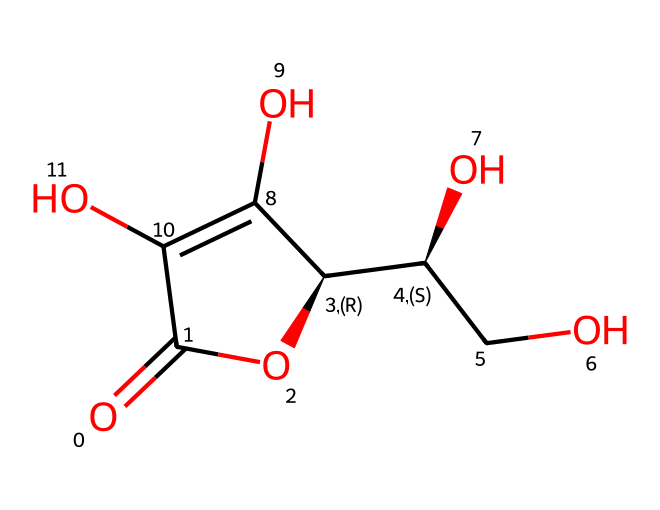What is the name of this chemical? The SMILES representation provided corresponds to ascorbic acid, commonly known as Vitamin C. The presence of multiple hydroxyl (OH) groups and a lactone structure indicates its identity.
Answer: ascorbic acid How many carbon atoms are in this structure? By examining the SMILES representation, we count the number of carbon atoms present. The structure has six carbon atoms indicated by the branching and the backbone of the molecule.
Answer: six How many hydroxyl groups are in Vitamin C? In the provided structure, each -OH group is a hydroxyl group. By identifying the distinct hydroxyl groups in the structure, we find that there are four hydroxyl groups.
Answer: four What is the primary function of Vitamin C in muscle recovery? Vitamin C acts as an antioxidant, helping to reduce oxidative stress in muscle tissues following exercise. Its ability to scavenge free radicals contributes to muscle recovery.
Answer: antioxidant What does the chemical structure suggest about its solubility? The presence of multiple hydroxyl (-OH) groups in the structure indicates that Vitamin C is polar and can form hydrogen bonds with water, suggesting good solubility in water.
Answer: soluble in water Why does Vitamin C have antioxidant properties? The antioxidant properties of Vitamin C can be attributed to its ability to donate electrons, neutralizing free radicals, which helps reduce oxidative damage during muscle recovery.
Answer: electron donor 